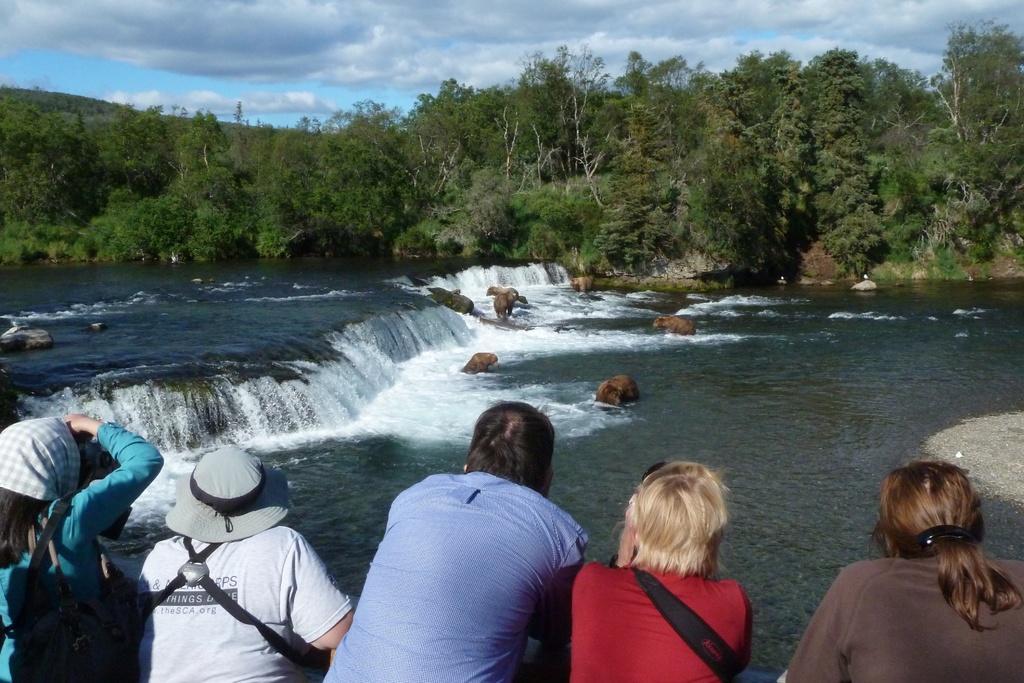Describe this image in one or two sentences. There are some people standing wearing hat and scarf. In the back there is a river with small waterfall and rocks. In the background there are trees and sky with clouds. 